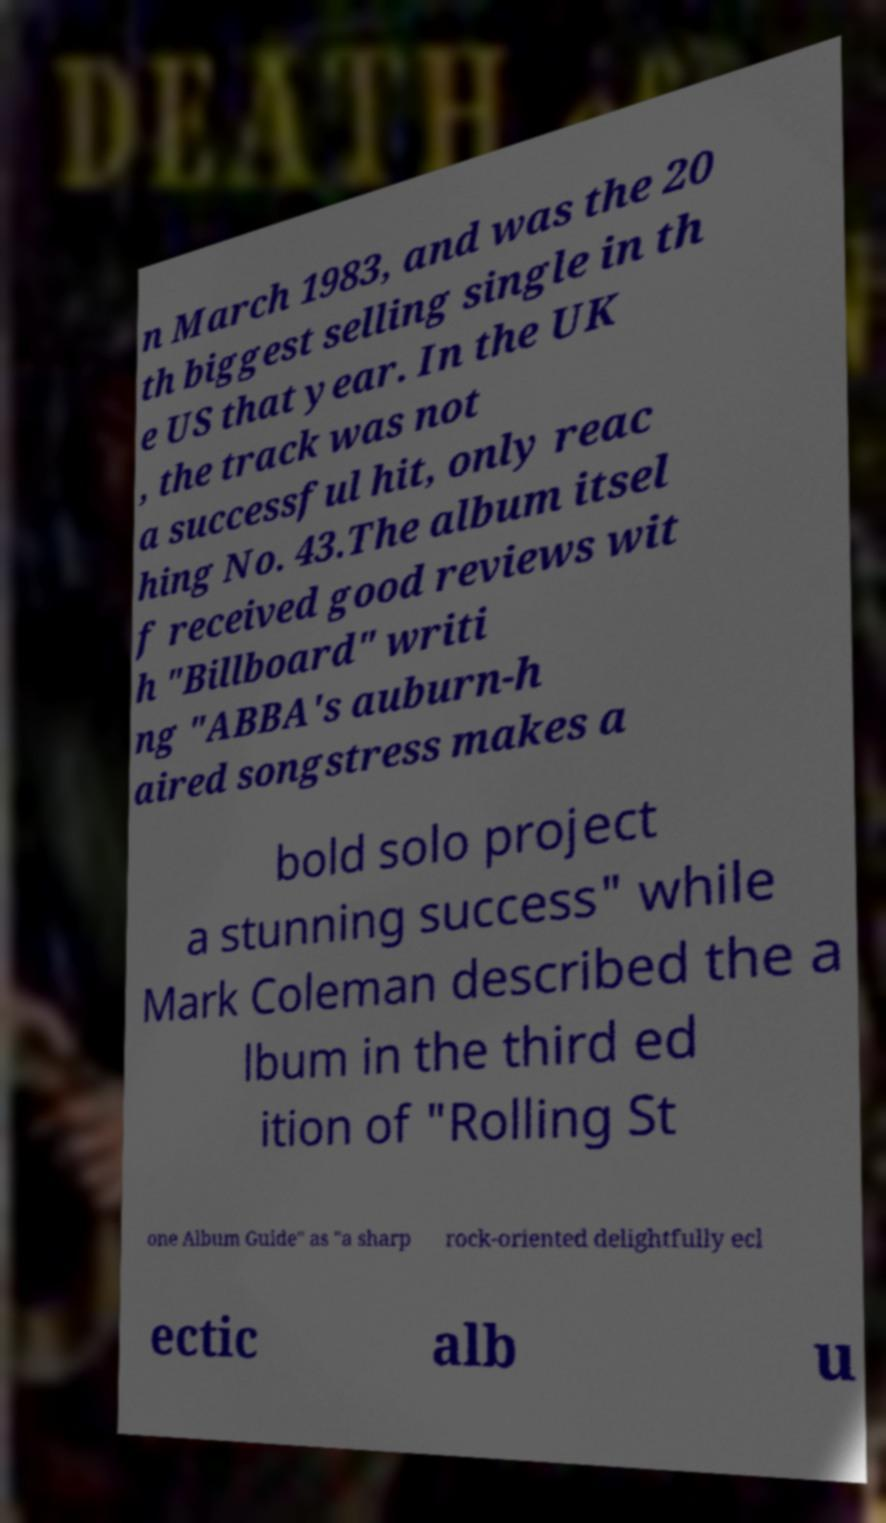Can you accurately transcribe the text from the provided image for me? n March 1983, and was the 20 th biggest selling single in th e US that year. In the UK , the track was not a successful hit, only reac hing No. 43.The album itsel f received good reviews wit h "Billboard" writi ng "ABBA's auburn-h aired songstress makes a bold solo project a stunning success" while Mark Coleman described the a lbum in the third ed ition of "Rolling St one Album Guide" as "a sharp rock-oriented delightfully ecl ectic alb u 